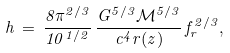Convert formula to latex. <formula><loc_0><loc_0><loc_500><loc_500>h \, = \, \frac { 8 \pi ^ { 2 / 3 } } { 1 0 ^ { 1 / 2 } } \, \frac { G ^ { 5 / 3 } { \mathcal { M } } ^ { 5 / 3 } } { c ^ { 4 } r ( z ) } \, f _ { r } ^ { 2 / 3 } ,</formula> 